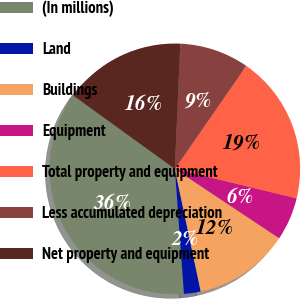Convert chart. <chart><loc_0><loc_0><loc_500><loc_500><pie_chart><fcel>(In millions)<fcel>Land<fcel>Buildings<fcel>Equipment<fcel>Total property and equipment<fcel>Less accumulated depreciation<fcel>Net property and equipment<nl><fcel>36.11%<fcel>2.16%<fcel>12.35%<fcel>5.55%<fcel>19.14%<fcel>8.95%<fcel>15.74%<nl></chart> 